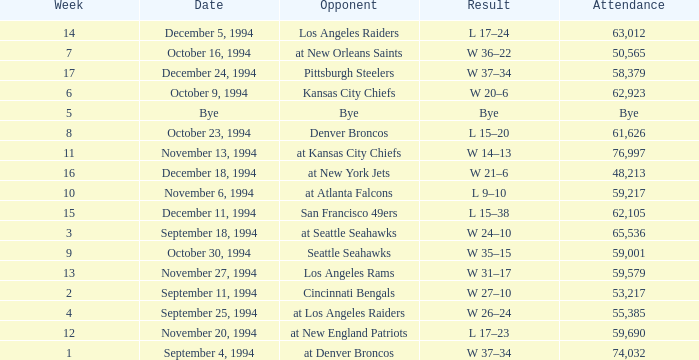In the game on or before week 9, who was the opponent when the attendance was 61,626? Denver Broncos. 